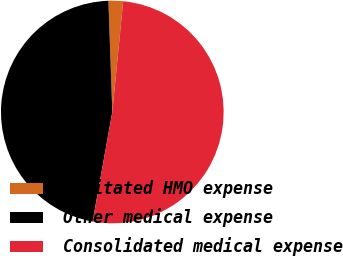<chart> <loc_0><loc_0><loc_500><loc_500><pie_chart><fcel>Capitated HMO expense<fcel>Other medical expense<fcel>Consolidated medical expense<nl><fcel>2.12%<fcel>46.61%<fcel>51.27%<nl></chart> 